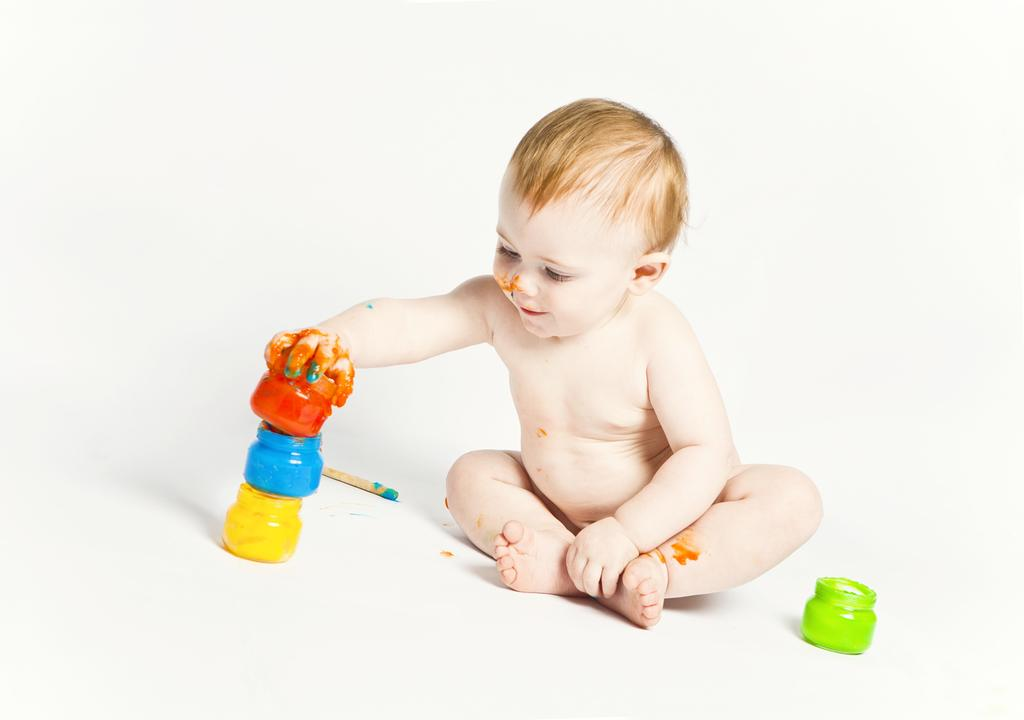What is the main subject of the image? The main subject of the image is a kid. What is the kid holding in the image? The kid is holding a paint bottle. Are there any other paint bottles visible in the image? Yes, there are different color paint bottles in the image. What else can be seen in the image? There is a stick in the image. What is the color of the background in the image? The background of the image is white in color. What type of pet is sitting next to the kid in the image? There is no pet present in the image; it only features the kid, paint bottles, and a stick. 